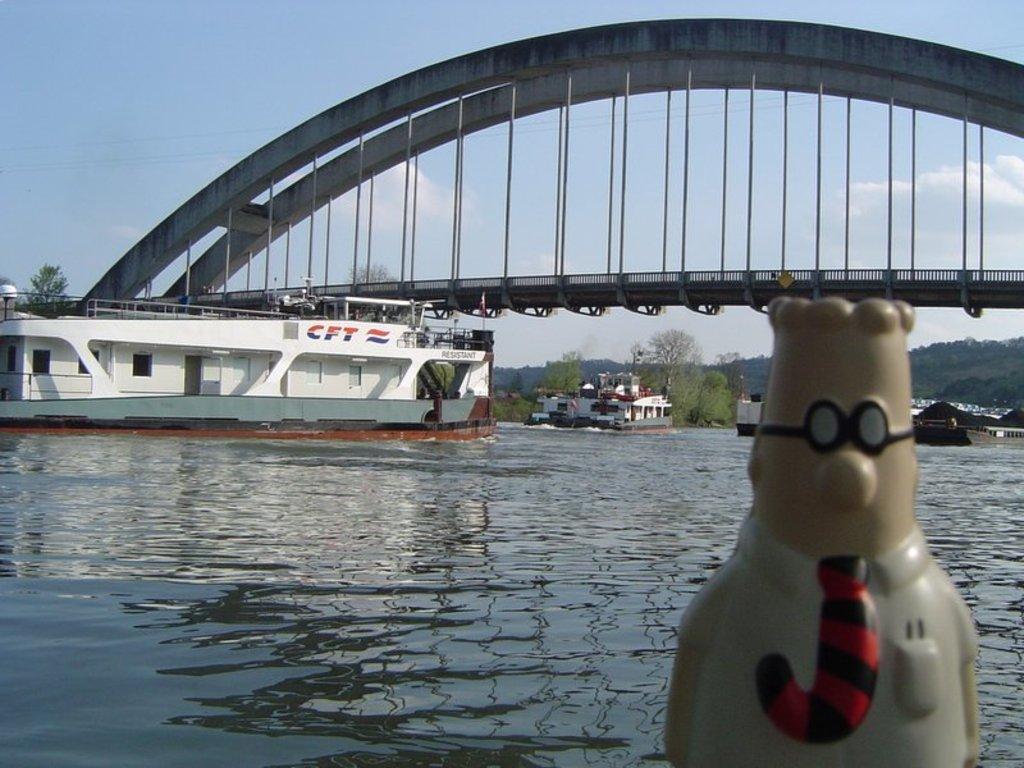Describe this image in one or two sentences. In this picture we can see a sculpture and few ships on the water, in the background we can see few trees, clouds and a bridge over the water. 